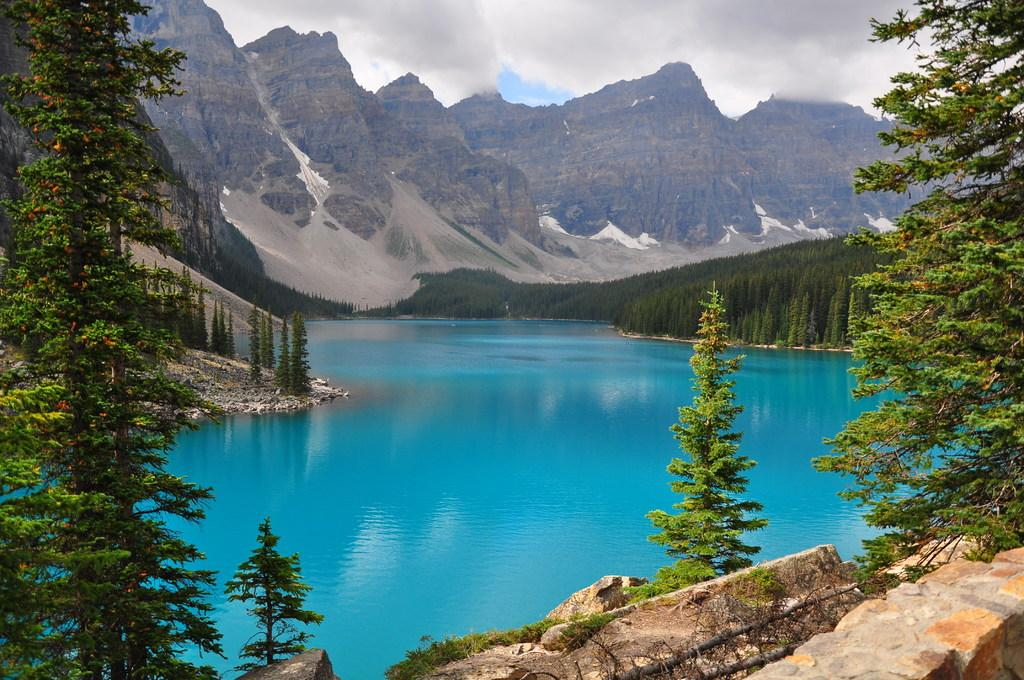What type of natural environment is depicted in the image? The image features trees, water, mountains, and the sky, indicating a natural environment. Can you describe the water in the image? There is water visible in the image, but its specific characteristics are not mentioned in the facts. What is the condition of the sky in the image? The sky is visible in the image, and clouds are present. What type of terrain can be seen in the image? The image features mountains, which indicate a mountainous terrain. Where is the faucet located in the image? There is no faucet present in the image; it is a natural environment featuring trees, water, mountains, and the sky. How many men can be seen interacting with the mountains in the image? There are no men present in the image; it is a natural environment featuring trees, water, mountains, and the sky. 